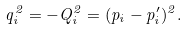<formula> <loc_0><loc_0><loc_500><loc_500>q _ { i } ^ { 2 } = - Q _ { i } ^ { 2 } = ( p _ { i } - p _ { i } ^ { \prime } ) ^ { 2 } .</formula> 